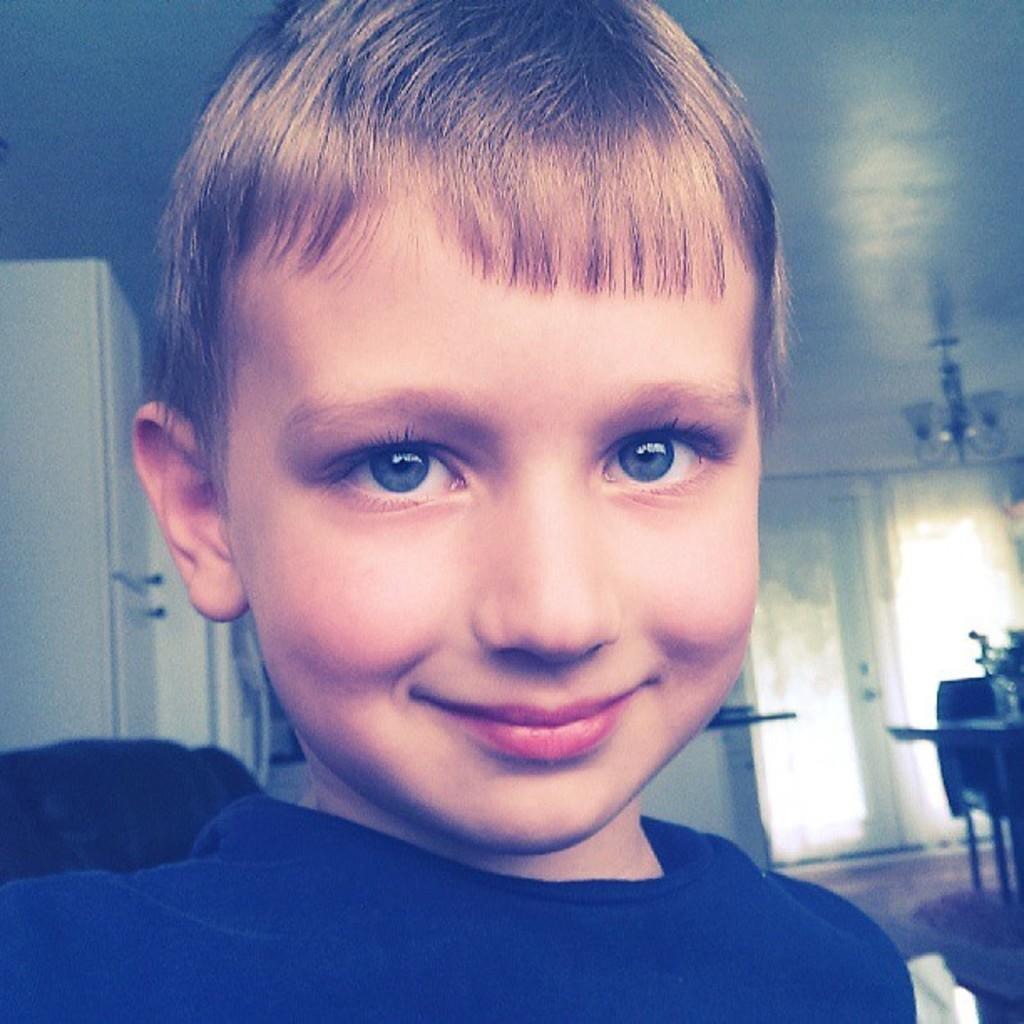What is the main subject of the image? The main subject of the image is a kid. What can be observed about the kid's attire? The kid is wearing clothes. Where is the door located in the image? The door is on the right side of the image. What part of the room can be seen in the top right of the image? There is a ceiling visible in the top right of the image. What title is the kid holding in the image? There is no title visible in the image; the kid is not holding anything. How many geese are present in the image? There are no geese present in the image. 